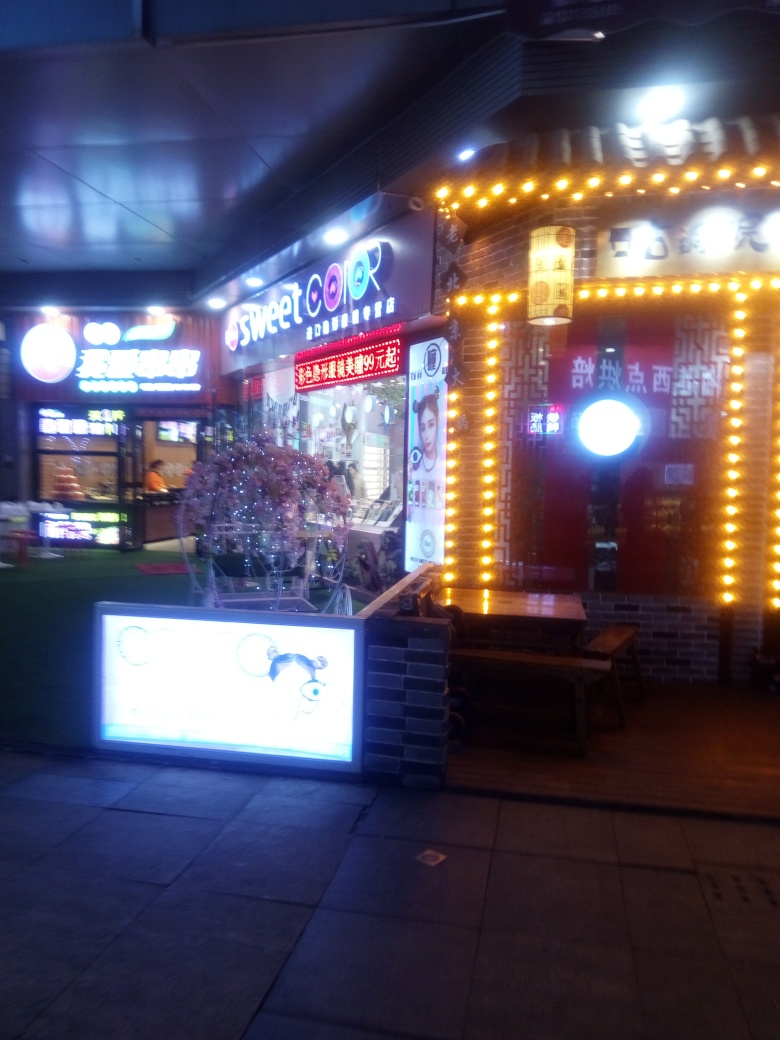What is the quality of the background in the image? The background of the image features a beauty salon at night, illuminated by numerous bright lights. While the overall photo quality is somewhat low and blurry—likely due to low lighting conditions and a moving camera, the salon's vibrant lights and signage are still clearly visible. 